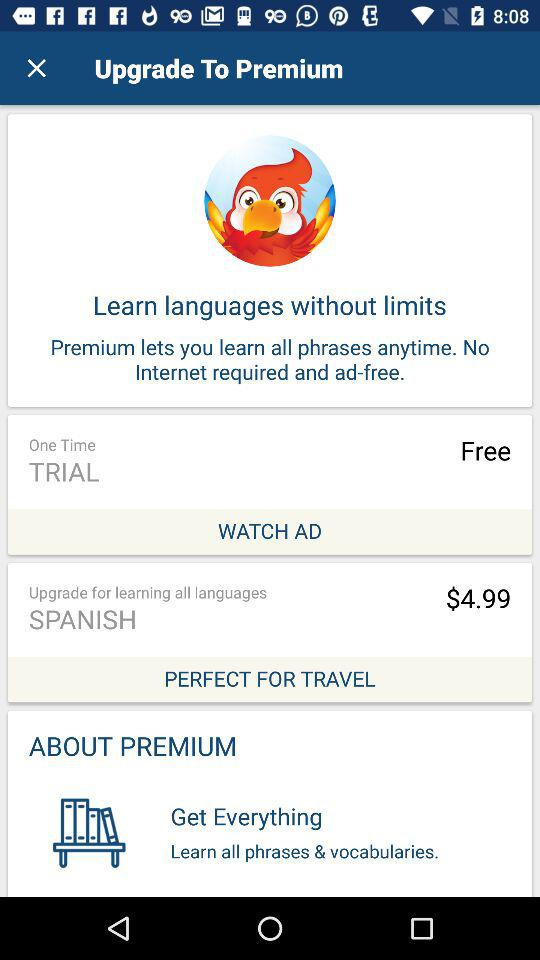What language is shown? The shown language is Spanish. 